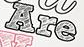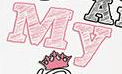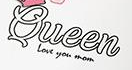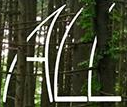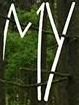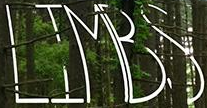Read the text from these images in sequence, separated by a semicolon. Are; My; Queen; ALL; MY; LIMBS 